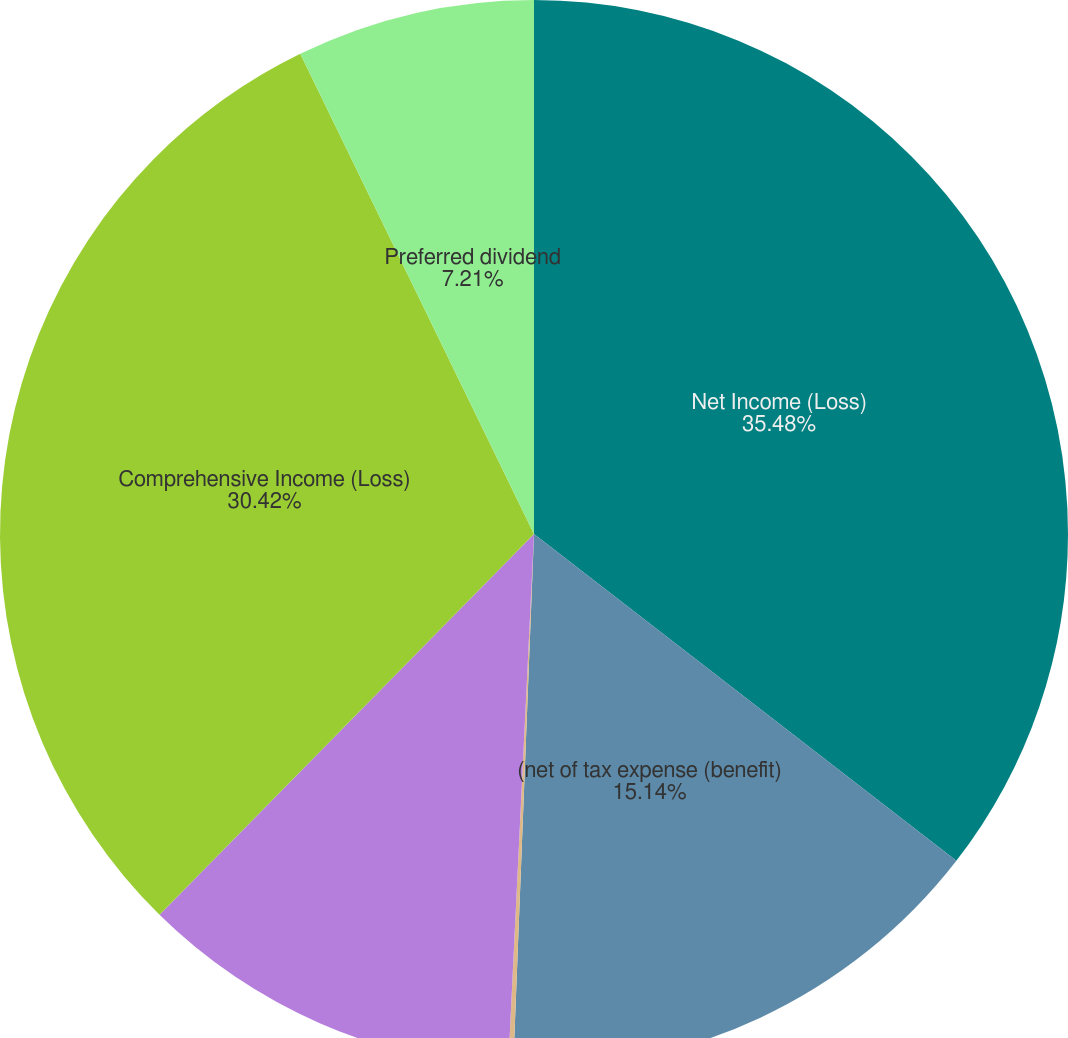Convert chart to OTSL. <chart><loc_0><loc_0><loc_500><loc_500><pie_chart><fcel>Net Income (Loss)<fcel>(net of tax expense (benefit)<fcel>(net of tax benefit of 403 689<fcel>Other comprehensive income<fcel>Comprehensive Income (Loss)<fcel>Preferred dividend<nl><fcel>35.48%<fcel>15.14%<fcel>0.15%<fcel>11.6%<fcel>30.42%<fcel>7.21%<nl></chart> 